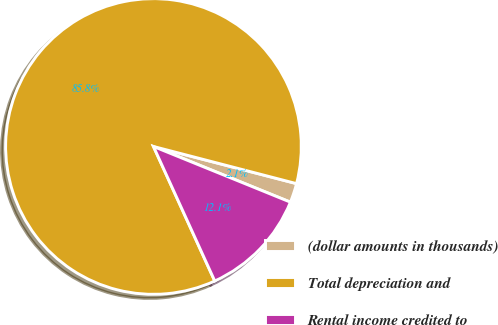Convert chart. <chart><loc_0><loc_0><loc_500><loc_500><pie_chart><fcel>(dollar amounts in thousands)<fcel>Total depreciation and<fcel>Rental income credited to<nl><fcel>2.1%<fcel>85.84%<fcel>12.05%<nl></chart> 